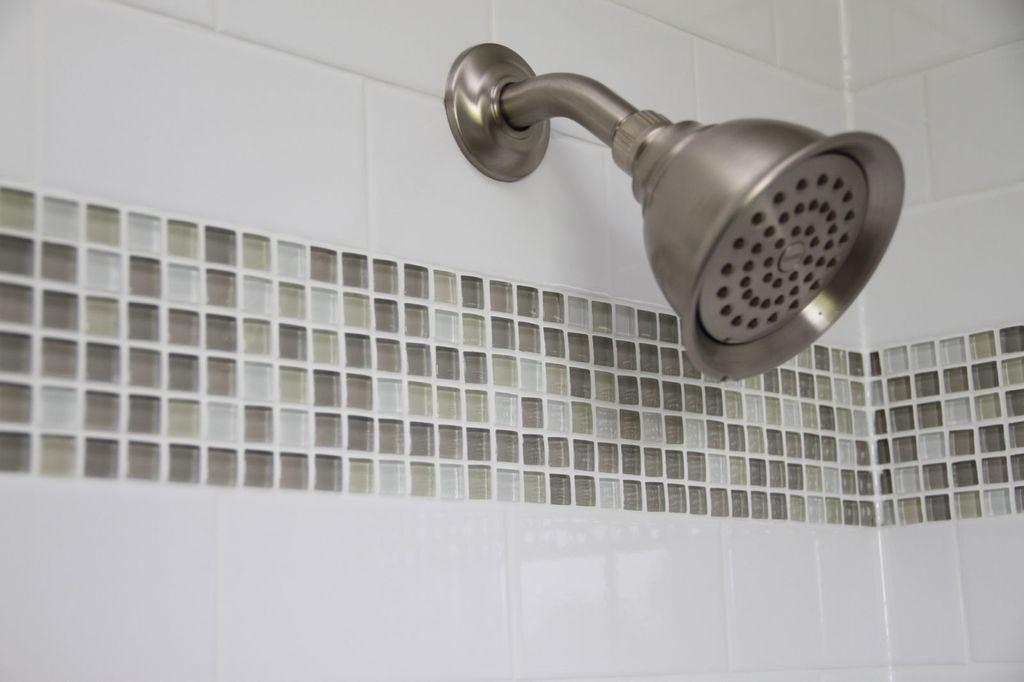What is the main feature of the image? There is a shower in the image. What else can be seen in the image besides the shower? There is a road and a wall in the image. What type of reward can be seen hanging from the shower in the image? There is no reward present in the image, as it features a shower, a road, and a wall. What kind of creature is interacting with the shower in the image? There is no creature interacting with the shower in the image; it is a still image of a shower, a road, and a wall. 